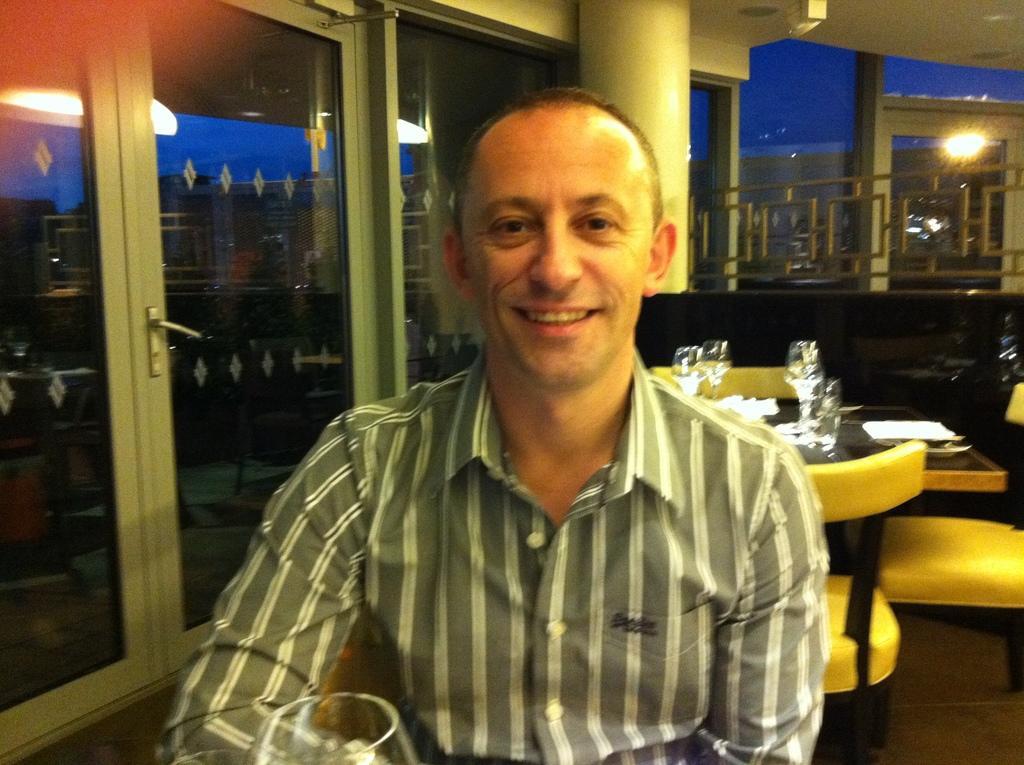How would you summarize this image in a sentence or two? In front of the image there is a person having a smile on his face. In front of him there is a glass. Behind him there are chairs. There is a table. On top of it there are glasses and tissues. There is a railing. On top of the image there are lights. On the left side of the image there are glass doors through which we can see buildings and sky. 